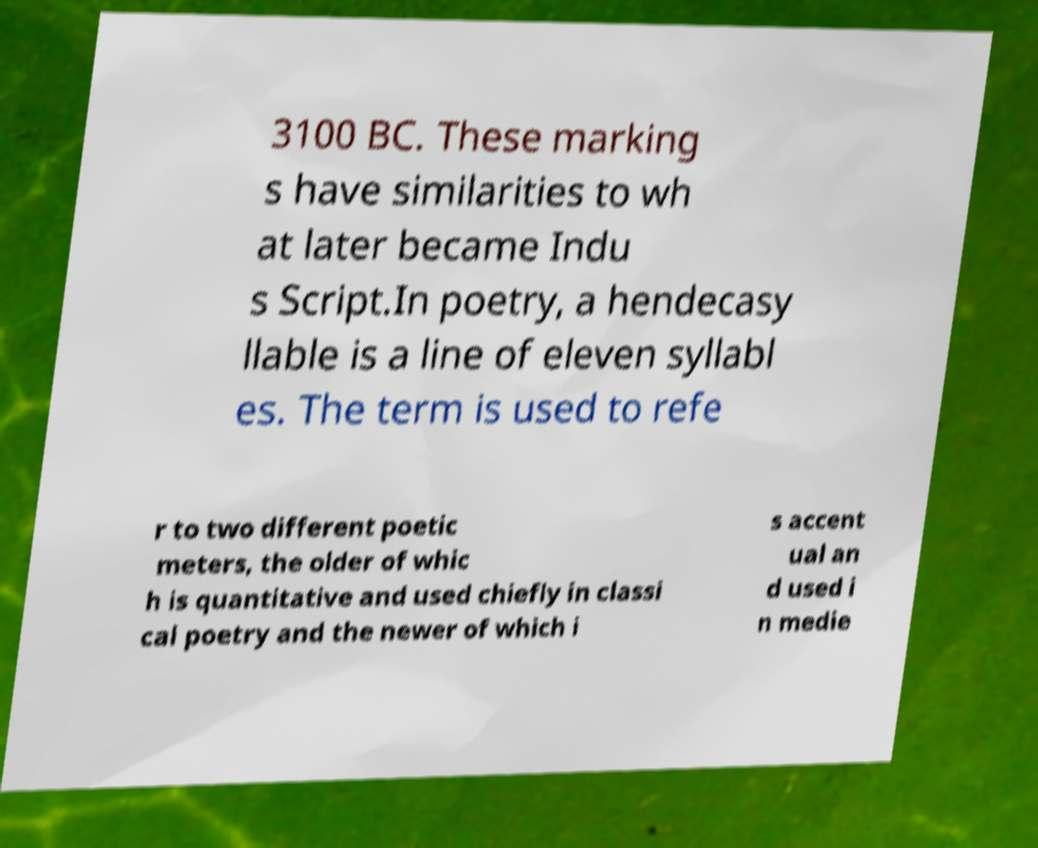I need the written content from this picture converted into text. Can you do that? 3100 BC. These marking s have similarities to wh at later became Indu s Script.In poetry, a hendecasy llable is a line of eleven syllabl es. The term is used to refe r to two different poetic meters, the older of whic h is quantitative and used chiefly in classi cal poetry and the newer of which i s accent ual an d used i n medie 